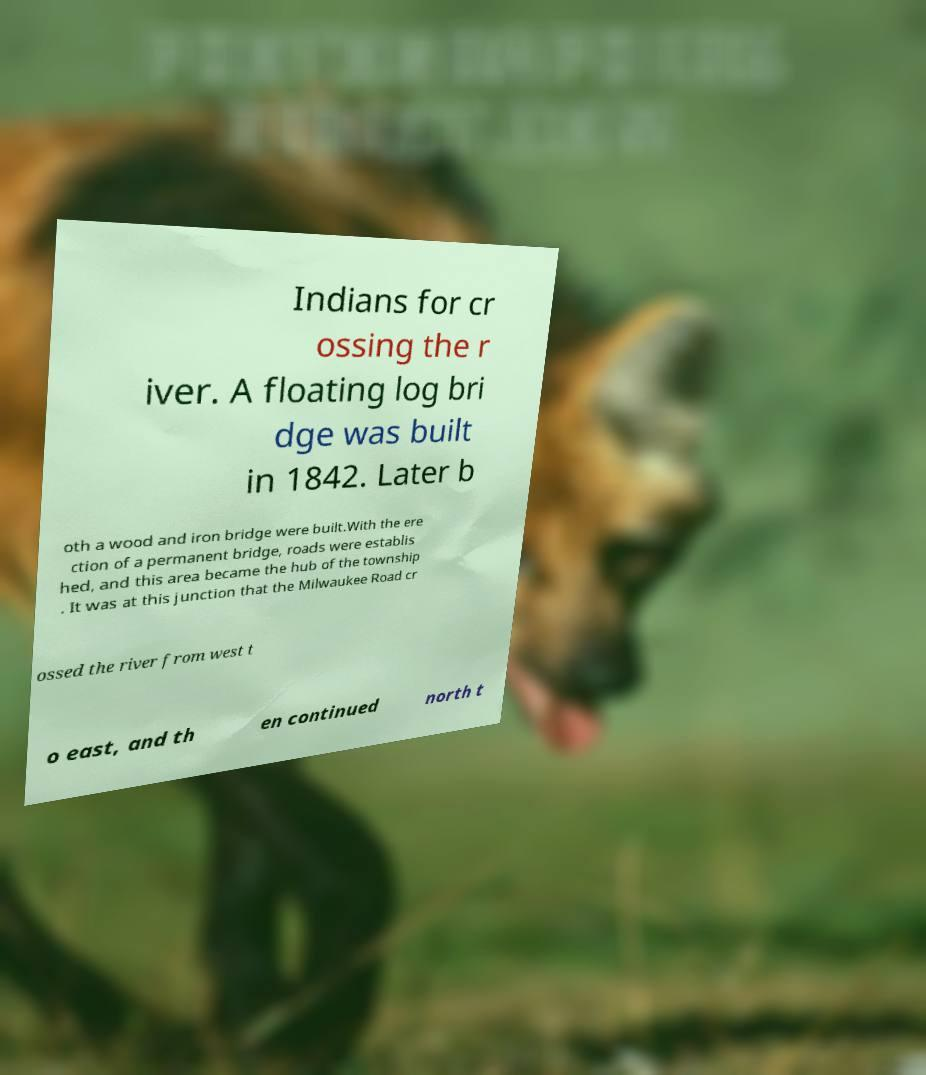Can you read and provide the text displayed in the image?This photo seems to have some interesting text. Can you extract and type it out for me? Indians for cr ossing the r iver. A floating log bri dge was built in 1842. Later b oth a wood and iron bridge were built.With the ere ction of a permanent bridge, roads were establis hed, and this area became the hub of the township . It was at this junction that the Milwaukee Road cr ossed the river from west t o east, and th en continued north t 